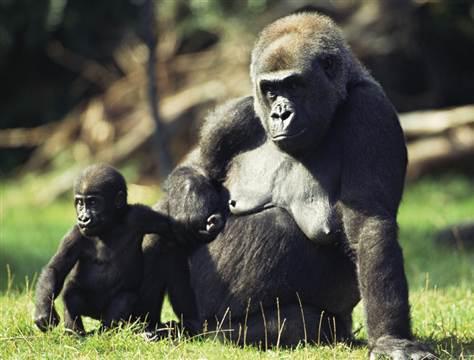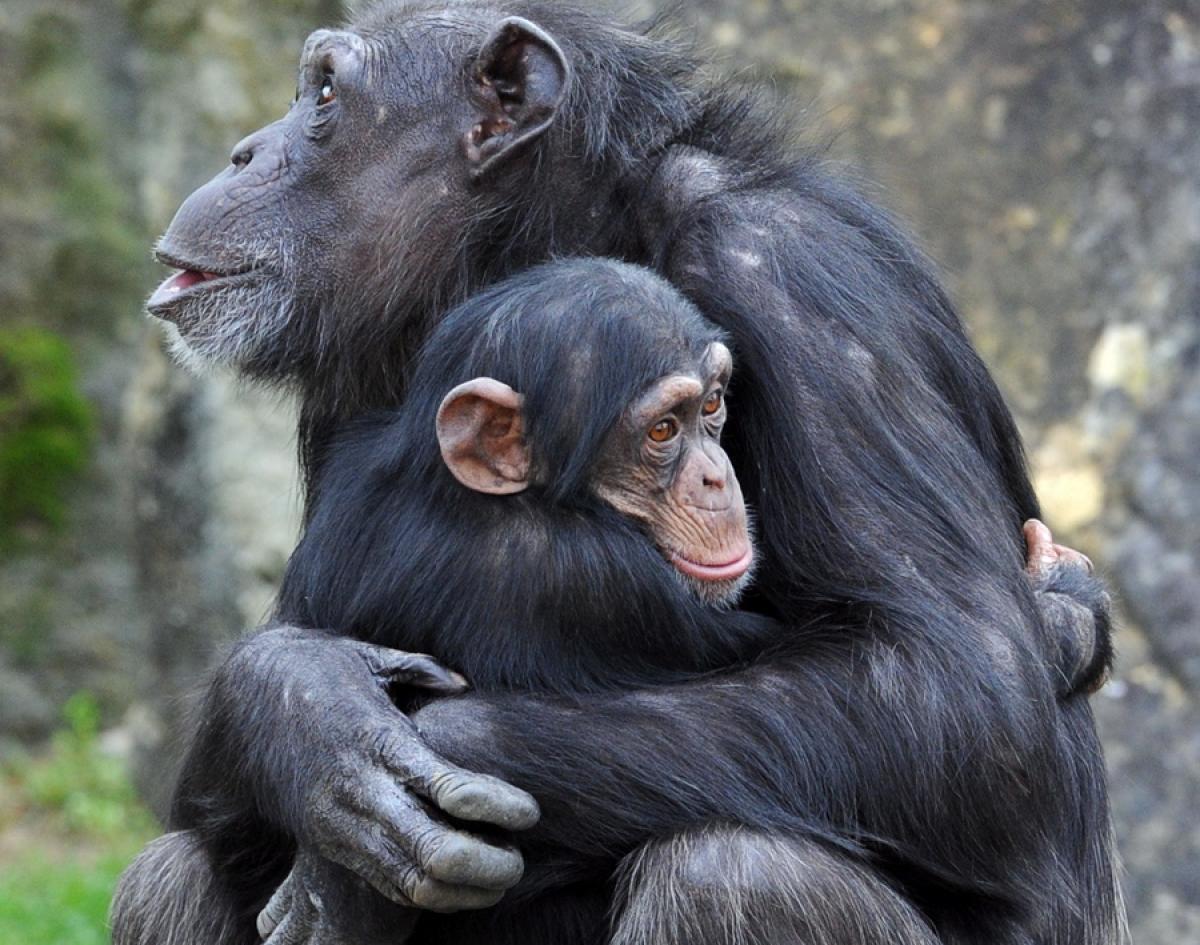The first image is the image on the left, the second image is the image on the right. For the images displayed, is the sentence "An image shows an adult chimpanzee hugging a younger awake chimpanzee to its chest." factually correct? Answer yes or no. Yes. The first image is the image on the left, the second image is the image on the right. For the images shown, is this caption "A single young primate is lying down in the image on the right." true? Answer yes or no. No. 